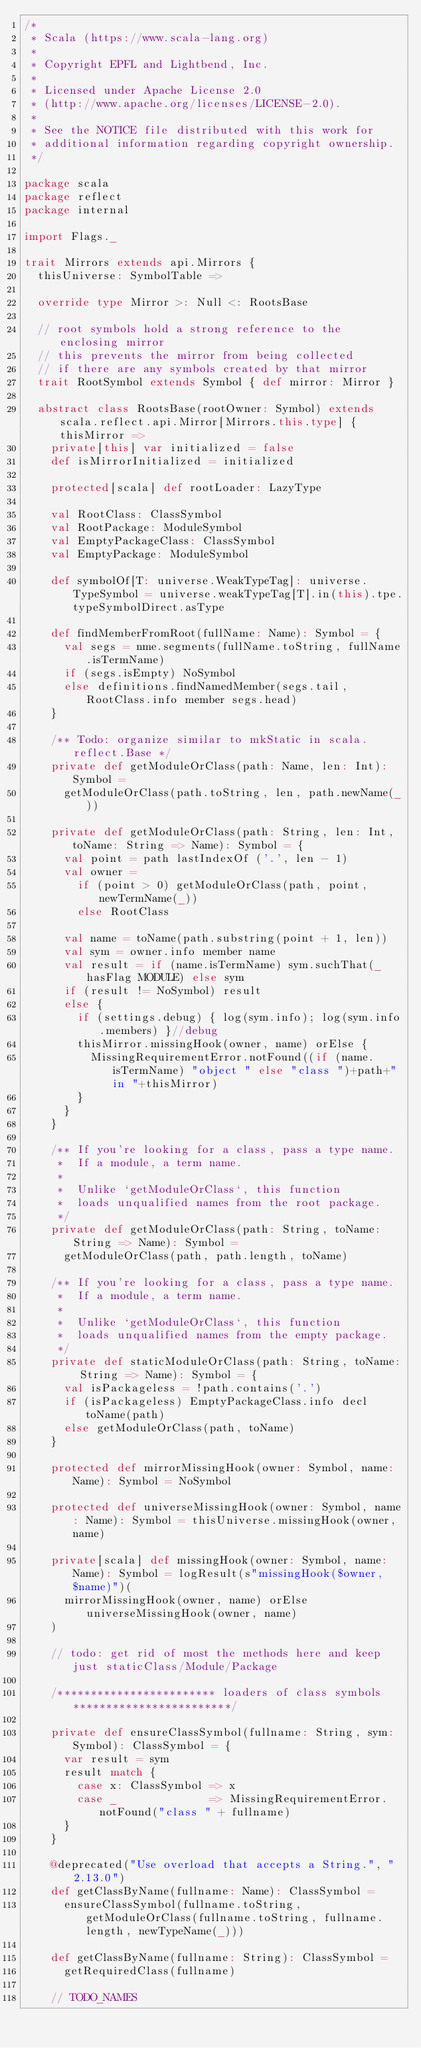Convert code to text. <code><loc_0><loc_0><loc_500><loc_500><_Scala_>/*
 * Scala (https://www.scala-lang.org)
 *
 * Copyright EPFL and Lightbend, Inc.
 *
 * Licensed under Apache License 2.0
 * (http://www.apache.org/licenses/LICENSE-2.0).
 *
 * See the NOTICE file distributed with this work for
 * additional information regarding copyright ownership.
 */

package scala
package reflect
package internal

import Flags._

trait Mirrors extends api.Mirrors {
  thisUniverse: SymbolTable =>

  override type Mirror >: Null <: RootsBase

  // root symbols hold a strong reference to the enclosing mirror
  // this prevents the mirror from being collected
  // if there are any symbols created by that mirror
  trait RootSymbol extends Symbol { def mirror: Mirror }

  abstract class RootsBase(rootOwner: Symbol) extends scala.reflect.api.Mirror[Mirrors.this.type] { thisMirror =>
    private[this] var initialized = false
    def isMirrorInitialized = initialized

    protected[scala] def rootLoader: LazyType

    val RootClass: ClassSymbol
    val RootPackage: ModuleSymbol
    val EmptyPackageClass: ClassSymbol
    val EmptyPackage: ModuleSymbol

    def symbolOf[T: universe.WeakTypeTag]: universe.TypeSymbol = universe.weakTypeTag[T].in(this).tpe.typeSymbolDirect.asType

    def findMemberFromRoot(fullName: Name): Symbol = {
      val segs = nme.segments(fullName.toString, fullName.isTermName)
      if (segs.isEmpty) NoSymbol
      else definitions.findNamedMember(segs.tail, RootClass.info member segs.head)
    }

    /** Todo: organize similar to mkStatic in scala.reflect.Base */
    private def getModuleOrClass(path: Name, len: Int): Symbol =
      getModuleOrClass(path.toString, len, path.newName(_))

    private def getModuleOrClass(path: String, len: Int, toName: String => Name): Symbol = {
      val point = path lastIndexOf ('.', len - 1)
      val owner =
        if (point > 0) getModuleOrClass(path, point, newTermName(_))
        else RootClass

      val name = toName(path.substring(point + 1, len))
      val sym = owner.info member name
      val result = if (name.isTermName) sym.suchThat(_ hasFlag MODULE) else sym
      if (result != NoSymbol) result
      else {
        if (settings.debug) { log(sym.info); log(sym.info.members) }//debug
        thisMirror.missingHook(owner, name) orElse {
          MissingRequirementError.notFound((if (name.isTermName) "object " else "class ")+path+" in "+thisMirror)
        }
      }
    }

    /** If you're looking for a class, pass a type name.
     *  If a module, a term name.
     *
     *  Unlike `getModuleOrClass`, this function
     *  loads unqualified names from the root package.
     */
    private def getModuleOrClass(path: String, toName: String => Name): Symbol =
      getModuleOrClass(path, path.length, toName)

    /** If you're looking for a class, pass a type name.
     *  If a module, a term name.
     *
     *  Unlike `getModuleOrClass`, this function
     *  loads unqualified names from the empty package.
     */
    private def staticModuleOrClass(path: String, toName: String => Name): Symbol = {
      val isPackageless = !path.contains('.')
      if (isPackageless) EmptyPackageClass.info decl toName(path)
      else getModuleOrClass(path, toName)
    }

    protected def mirrorMissingHook(owner: Symbol, name: Name): Symbol = NoSymbol

    protected def universeMissingHook(owner: Symbol, name: Name): Symbol = thisUniverse.missingHook(owner, name)

    private[scala] def missingHook(owner: Symbol, name: Name): Symbol = logResult(s"missingHook($owner, $name)")(
      mirrorMissingHook(owner, name) orElse universeMissingHook(owner, name)
    )

    // todo: get rid of most the methods here and keep just staticClass/Module/Package

    /************************ loaders of class symbols ************************/

    private def ensureClassSymbol(fullname: String, sym: Symbol): ClassSymbol = {
      var result = sym
      result match {
        case x: ClassSymbol => x
        case _              => MissingRequirementError.notFound("class " + fullname)
      }
    }

    @deprecated("Use overload that accepts a String.", "2.13.0")
    def getClassByName(fullname: Name): ClassSymbol =
      ensureClassSymbol(fullname.toString, getModuleOrClass(fullname.toString, fullname.length, newTypeName(_)))

    def getClassByName(fullname: String): ClassSymbol =
      getRequiredClass(fullname)

    // TODO_NAMES</code> 